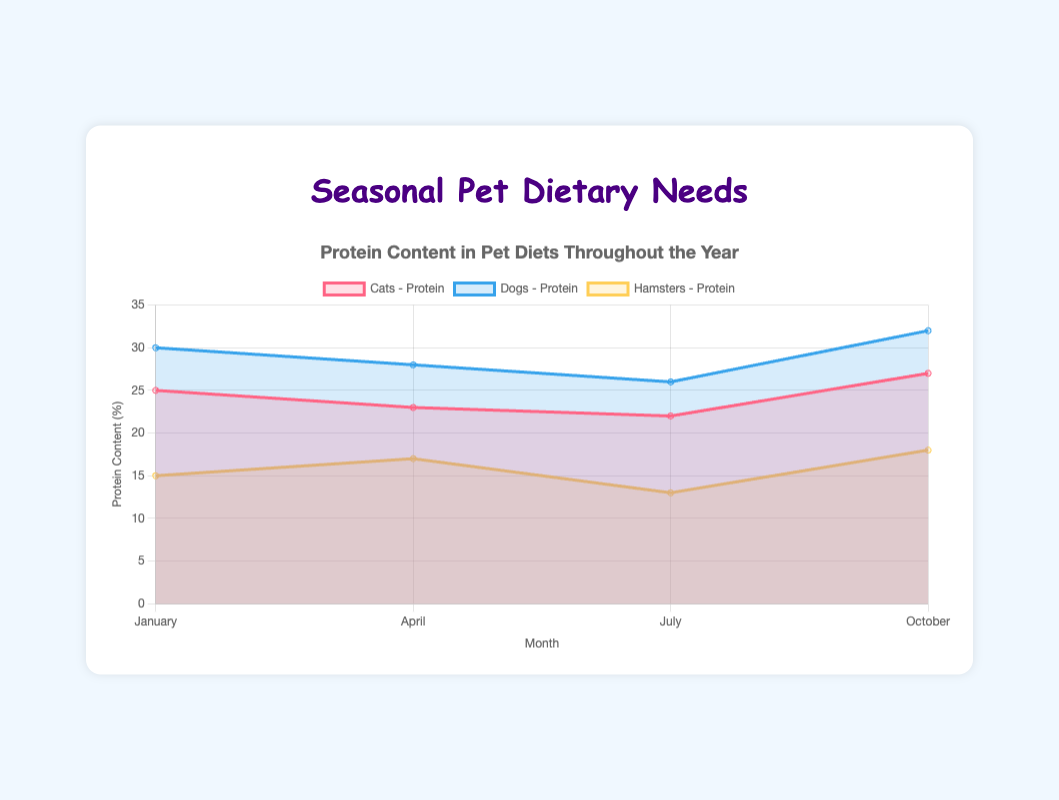What's the title of the figure? The title of the figure is displayed at the top and provides a brief description of the chart's content. It reads 'Protein Content in Pet Diets Throughout the Year'.
Answer: Protein Content in Pet Diets Throughout the Year In which month do dogs require the highest protein content? By examining the chart's lines representing the nutritional needs of dogs, we see that the highest protein content for dogs occurs in October.
Answer: October How many months are represented in the chart? The x-axis labels indicate the months represented in the chart. We see "January," "April," "July," and "October," which amount to 4 months.
Answer: 4 Which pet has the highest variation in protein content throughout the year? To find this, we compare the highest and lowest protein values for each pet: Cats (27-22=5), Dogs (32-26=6), Hamsters (18-13=5). The dogs have the highest variation of 6 points.
Answer: Dogs What is the average protein requirement for hamsters throughout the year? We calculate the average by summing the protein values for hamsters (15 + 17 + 13 + 18) and dividing by the number of months: (15 + 17 + 13 + 18) / 4 = 63 / 4 = 15.75.
Answer: 15.75 In which month do cats require the least amount of fiber? Checking the fiber data points for cats, the lowest value of fiber, 3, is observed in October.
Answer: October How does the protein requirement for cats change from January to July? From January to July, the protein requirement for cats decreases from 25 to 22.
Answer: Decreases Which pet requires the most protein in April? In April, we compare protein values: Cats (23), Dogs (28), and Hamsters (17). Dogs require the most protein, which is 28.
Answer: Dogs Compare the fiber needs of hamsters in January and July. By inspecting the chart, we see that hamsters' fiber needs increase from 10 in January to 12 in July.
Answer: Increase Which pet’s protein needs are the highest in July? The protein values for July are: Cats (22), Dogs (26), Hamsters (13). Dogs have the highest protein needs at 26 in July.
Answer: Dogs 